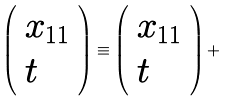Convert formula to latex. <formula><loc_0><loc_0><loc_500><loc_500>\left ( \begin{array} { l } { { x _ { 1 1 } } } \\ { t } \end{array} \right ) \equiv \left ( \begin{array} { l } { { x _ { 1 1 } } } \\ { t } \end{array} \right ) +</formula> 